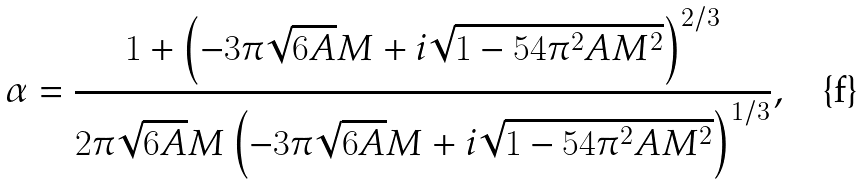Convert formula to latex. <formula><loc_0><loc_0><loc_500><loc_500>\alpha = \frac { 1 + \left ( - 3 \pi \sqrt { 6 A } M + i \sqrt { 1 - 5 4 \pi ^ { 2 } A { M ^ { 2 } } } \right ) ^ { 2 / 3 } } { 2 \pi \sqrt { 6 A } M \left ( - 3 \pi \sqrt { 6 A } M + i \sqrt { 1 - 5 4 \pi ^ { 2 } A M ^ { 2 } } \right ) ^ { 1 / 3 } } ,</formula> 